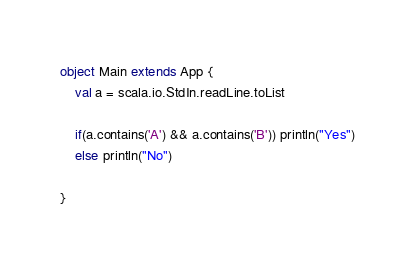<code> <loc_0><loc_0><loc_500><loc_500><_Scala_>object Main extends App {
	val a = scala.io.StdIn.readLine.toList

	if(a.contains('A') && a.contains('B')) println("Yes")
	else println("No")

}</code> 